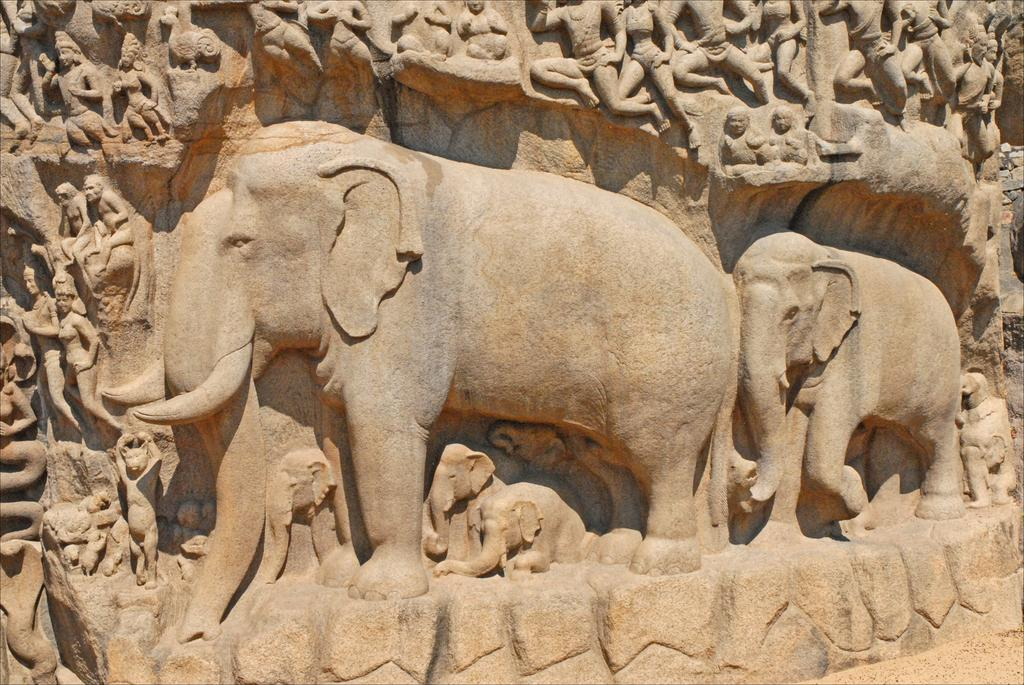What type of art is present in the image? There are sculptures in the image. Where are the sculptures located? The sculptures are on a platform. What color is the feather that is part of the sculpture in the image? There is no feather present in the image; the sculptures are made of different materials. 